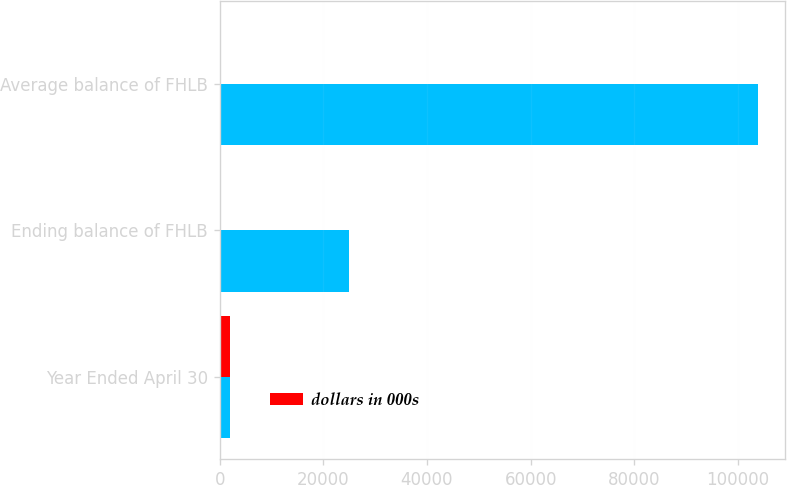Convert chart. <chart><loc_0><loc_0><loc_500><loc_500><stacked_bar_chart><ecel><fcel>Year Ended April 30<fcel>Ending balance of FHLB<fcel>Average balance of FHLB<nl><fcel>nan<fcel>2009<fcel>25000<fcel>103885<nl><fcel>dollars in 000s<fcel>2007<fcel>5.31<fcel>5.18<nl></chart> 